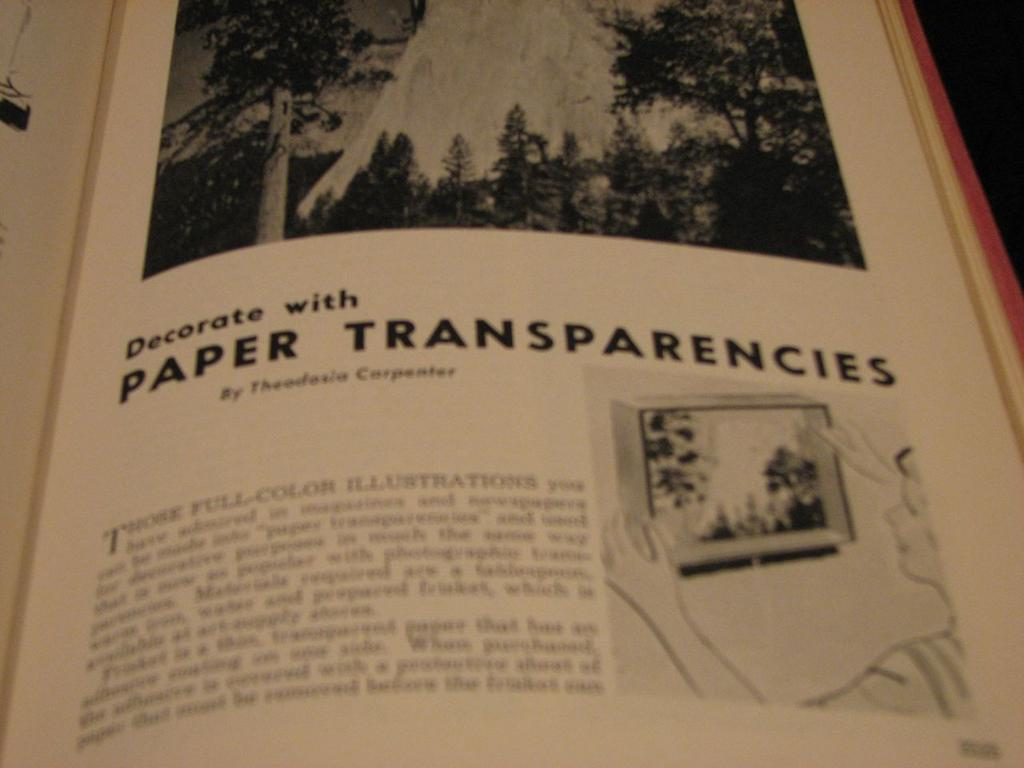<image>
Render a clear and concise summary of the photo. A book open to the page that reads decorate with paper transparencies. 